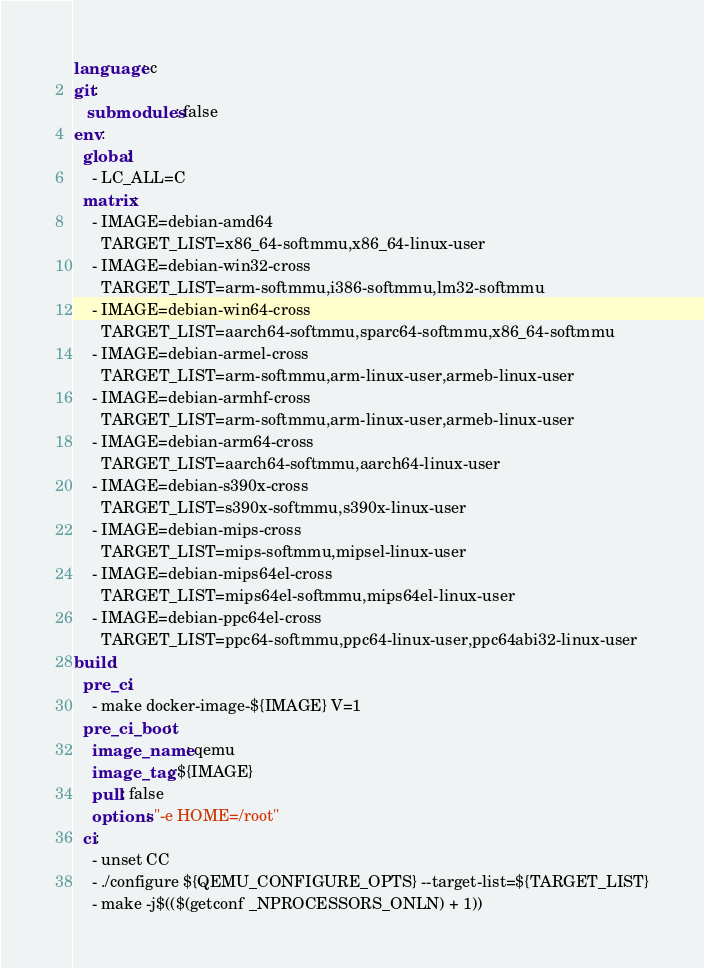<code> <loc_0><loc_0><loc_500><loc_500><_YAML_>language: c
git:
   submodules: false
env:
  global:
    - LC_ALL=C
  matrix:
    - IMAGE=debian-amd64
      TARGET_LIST=x86_64-softmmu,x86_64-linux-user
    - IMAGE=debian-win32-cross
      TARGET_LIST=arm-softmmu,i386-softmmu,lm32-softmmu
    - IMAGE=debian-win64-cross
      TARGET_LIST=aarch64-softmmu,sparc64-softmmu,x86_64-softmmu
    - IMAGE=debian-armel-cross
      TARGET_LIST=arm-softmmu,arm-linux-user,armeb-linux-user
    - IMAGE=debian-armhf-cross
      TARGET_LIST=arm-softmmu,arm-linux-user,armeb-linux-user
    - IMAGE=debian-arm64-cross
      TARGET_LIST=aarch64-softmmu,aarch64-linux-user
    - IMAGE=debian-s390x-cross
      TARGET_LIST=s390x-softmmu,s390x-linux-user
    - IMAGE=debian-mips-cross
      TARGET_LIST=mips-softmmu,mipsel-linux-user
    - IMAGE=debian-mips64el-cross
      TARGET_LIST=mips64el-softmmu,mips64el-linux-user
    - IMAGE=debian-ppc64el-cross
      TARGET_LIST=ppc64-softmmu,ppc64-linux-user,ppc64abi32-linux-user
build:
  pre_ci:
    - make docker-image-${IMAGE} V=1
  pre_ci_boot:
    image_name: qemu
    image_tag: ${IMAGE}
    pull: false
    options: "-e HOME=/root"
  ci:
    - unset CC
    - ./configure ${QEMU_CONFIGURE_OPTS} --target-list=${TARGET_LIST}
    - make -j$(($(getconf _NPROCESSORS_ONLN) + 1))
</code> 